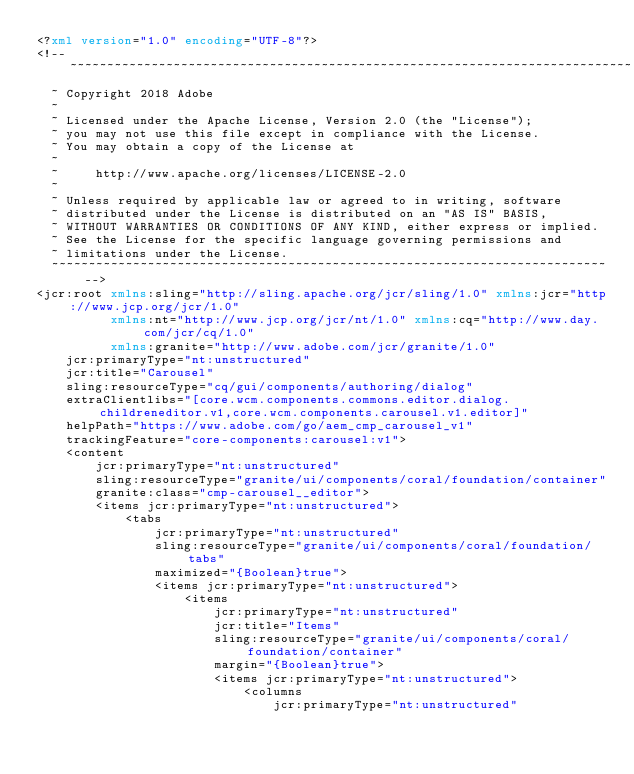Convert code to text. <code><loc_0><loc_0><loc_500><loc_500><_XML_><?xml version="1.0" encoding="UTF-8"?>
<!--~~~~~~~~~~~~~~~~~~~~~~~~~~~~~~~~~~~~~~~~~~~~~~~~~~~~~~~~~~~~~~~~~~~~~~~~~~~~
  ~ Copyright 2018 Adobe
  ~
  ~ Licensed under the Apache License, Version 2.0 (the "License");
  ~ you may not use this file except in compliance with the License.
  ~ You may obtain a copy of the License at
  ~
  ~     http://www.apache.org/licenses/LICENSE-2.0
  ~
  ~ Unless required by applicable law or agreed to in writing, software
  ~ distributed under the License is distributed on an "AS IS" BASIS,
  ~ WITHOUT WARRANTIES OR CONDITIONS OF ANY KIND, either express or implied.
  ~ See the License for the specific language governing permissions and
  ~ limitations under the License.
  ~~~~~~~~~~~~~~~~~~~~~~~~~~~~~~~~~~~~~~~~~~~~~~~~~~~~~~~~~~~~~~~~~~~~~~~~~~~-->
<jcr:root xmlns:sling="http://sling.apache.org/jcr/sling/1.0" xmlns:jcr="http://www.jcp.org/jcr/1.0"
          xmlns:nt="http://www.jcp.org/jcr/nt/1.0" xmlns:cq="http://www.day.com/jcr/cq/1.0"
          xmlns:granite="http://www.adobe.com/jcr/granite/1.0"
    jcr:primaryType="nt:unstructured"
    jcr:title="Carousel"
    sling:resourceType="cq/gui/components/authoring/dialog"
    extraClientlibs="[core.wcm.components.commons.editor.dialog.childreneditor.v1,core.wcm.components.carousel.v1.editor]"
    helpPath="https://www.adobe.com/go/aem_cmp_carousel_v1"
    trackingFeature="core-components:carousel:v1">
    <content
        jcr:primaryType="nt:unstructured"
        sling:resourceType="granite/ui/components/coral/foundation/container"
        granite:class="cmp-carousel__editor">
        <items jcr:primaryType="nt:unstructured">
            <tabs
                jcr:primaryType="nt:unstructured"
                sling:resourceType="granite/ui/components/coral/foundation/tabs"
                maximized="{Boolean}true">
                <items jcr:primaryType="nt:unstructured">
                    <items
                        jcr:primaryType="nt:unstructured"
                        jcr:title="Items"
                        sling:resourceType="granite/ui/components/coral/foundation/container"
                        margin="{Boolean}true">
                        <items jcr:primaryType="nt:unstructured">
                            <columns
                                jcr:primaryType="nt:unstructured"</code> 